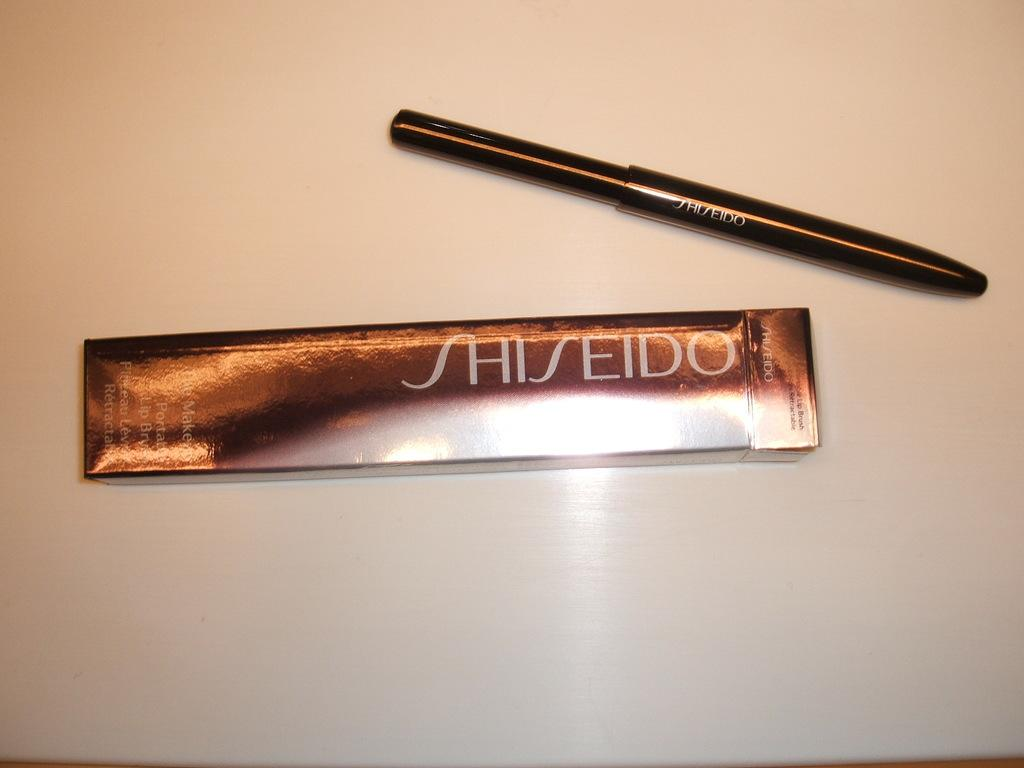What is the main object in the center of the image? There is a packet with text in the center of the image. What object is located next to the packet? The object next to the packet appears to be an eyeliner. Can you describe the background of the image? There is a table-like object in the background of the image. How many rings are visible on the table in the image? There are no rings visible on the table in the image. What type of trade is being conducted in the image? There is no trade being conducted in the image; it features a packet with text and an eyeliner. 